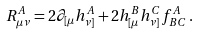Convert formula to latex. <formula><loc_0><loc_0><loc_500><loc_500>R _ { \mu \nu } ^ { A } = 2 \partial _ { [ \mu } h _ { \nu ] } ^ { A } + 2 h _ { [ \mu } ^ { B } h _ { \nu ] } ^ { C } f ^ { A } _ { B C } \, .</formula> 